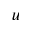Convert formula to latex. <formula><loc_0><loc_0><loc_500><loc_500>_ { u }</formula> 